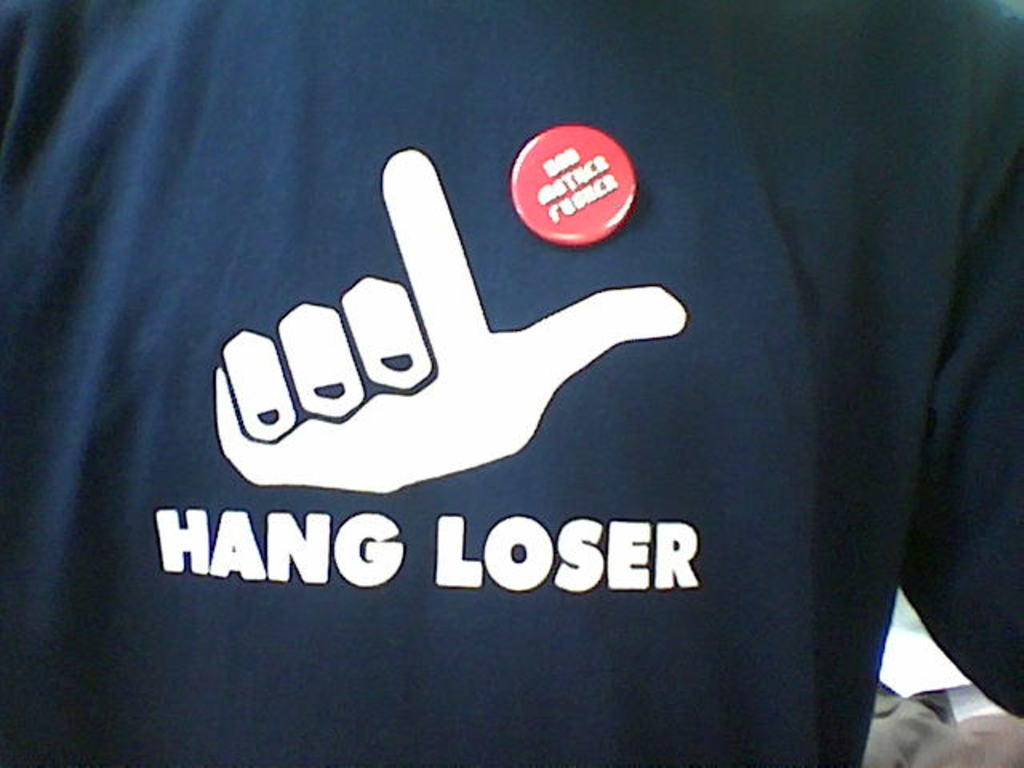Can you describe the main features of this image for me? The image prominently displays a t-shirt with a quirky, casual design. The navy blue t-shirt is adorned with a white graphic that creatively mimics the 'hang loose' hand gesture, but twists this normally positive symbol into 'HANG LOSER', leveraging wordplay and the relaxed hand gesture to deliver a humorous, self-deprecating joke. Accenting this playful attire is a red button, pinned near the chest, which reads 'I'm with stupid'. This classic humorous phrase usually points to a nearby person in jest, adding to the shirt's overall light-hearted, perhaps slightly ironic, vibe. 